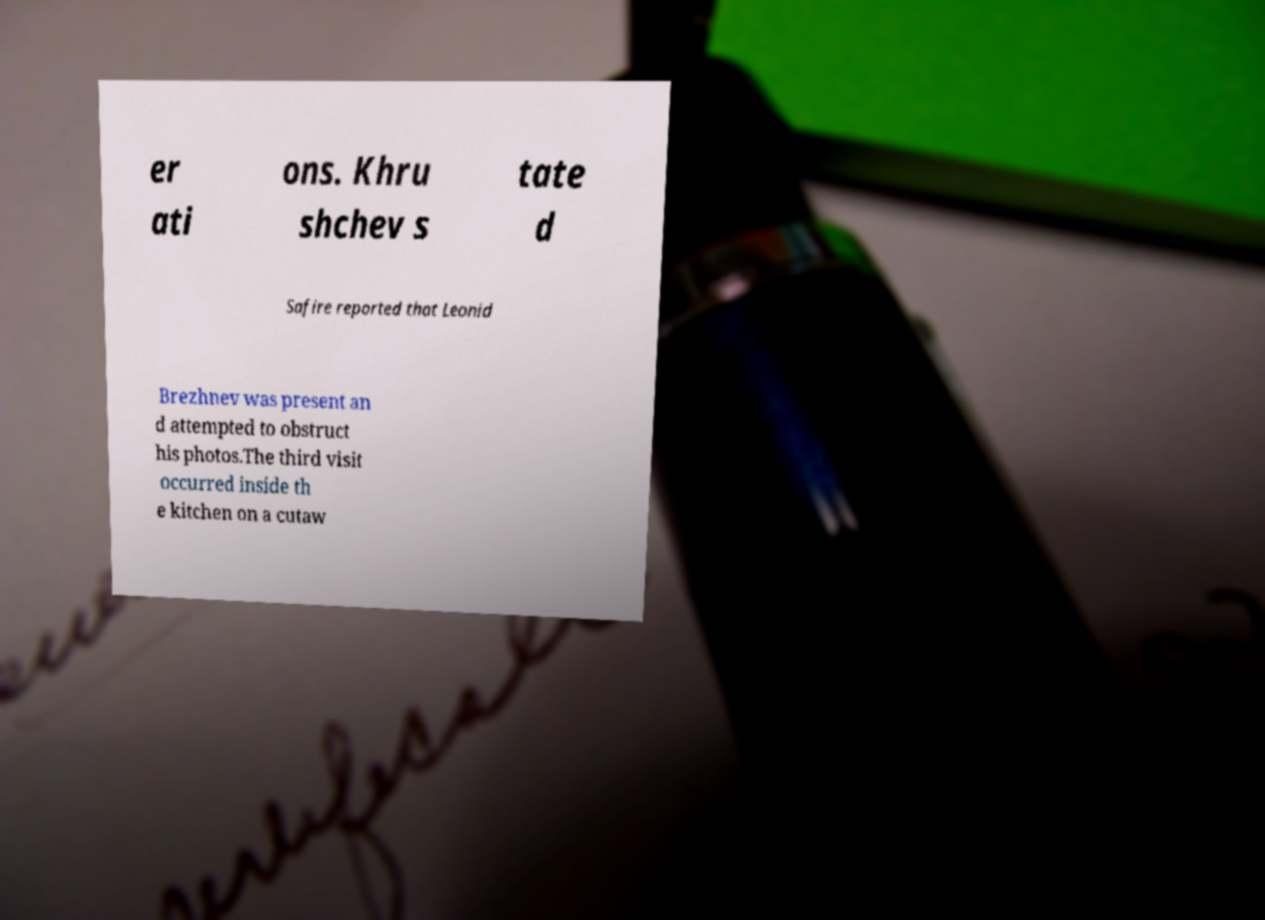I need the written content from this picture converted into text. Can you do that? er ati ons. Khru shchev s tate d Safire reported that Leonid Brezhnev was present an d attempted to obstruct his photos.The third visit occurred inside th e kitchen on a cutaw 